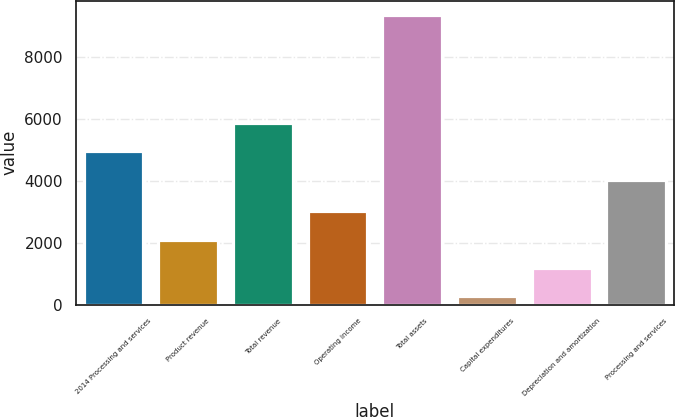<chart> <loc_0><loc_0><loc_500><loc_500><bar_chart><fcel>2014 Processing and services<fcel>Product revenue<fcel>Total revenue<fcel>Operating income<fcel>Total assets<fcel>Capital expenditures<fcel>Depreciation and amortization<fcel>Processing and services<nl><fcel>4939.5<fcel>2101<fcel>5844<fcel>3005.5<fcel>9337<fcel>292<fcel>1196.5<fcel>4035<nl></chart> 